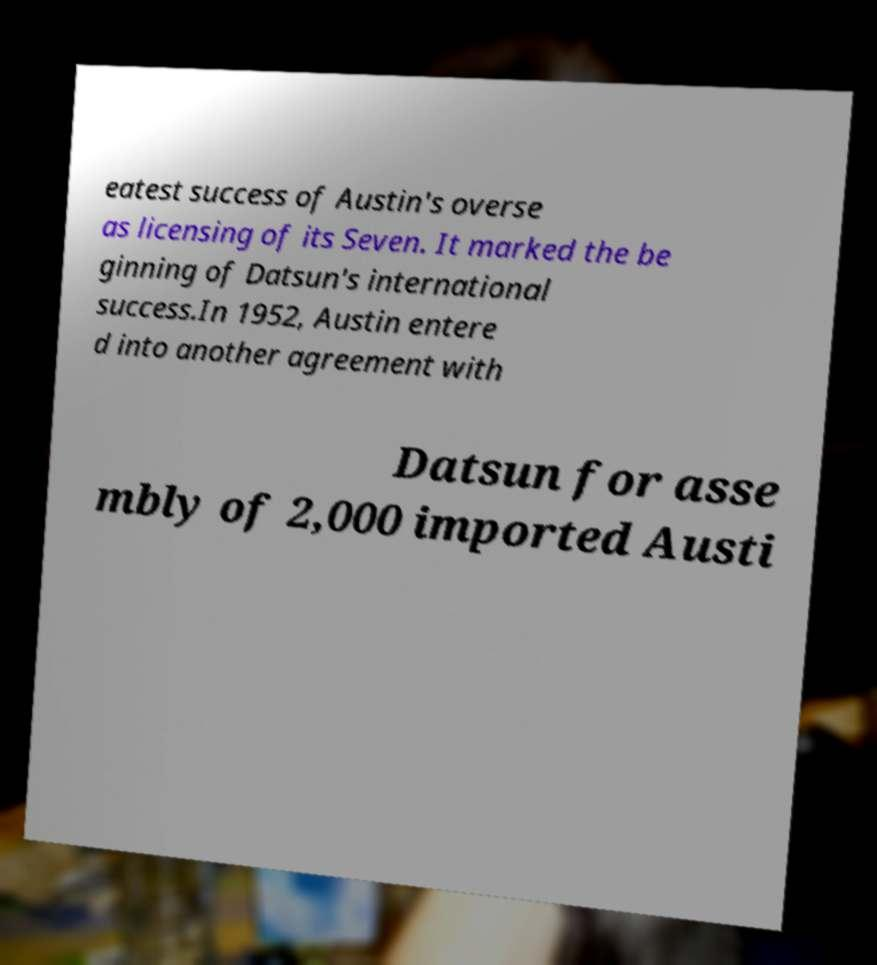What messages or text are displayed in this image? I need them in a readable, typed format. eatest success of Austin's overse as licensing of its Seven. It marked the be ginning of Datsun's international success.In 1952, Austin entere d into another agreement with Datsun for asse mbly of 2,000 imported Austi 